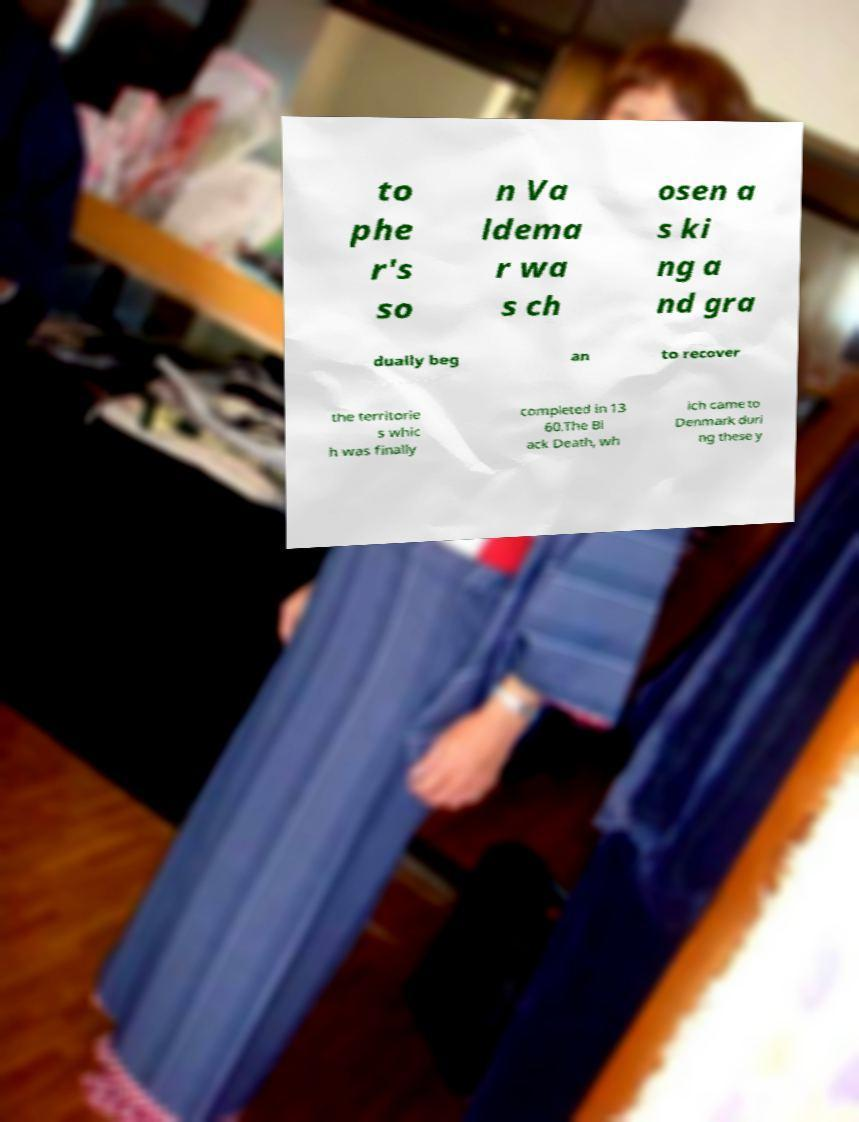Please identify and transcribe the text found in this image. to phe r's so n Va ldema r wa s ch osen a s ki ng a nd gra dually beg an to recover the territorie s whic h was finally completed in 13 60.The Bl ack Death, wh ich came to Denmark duri ng these y 